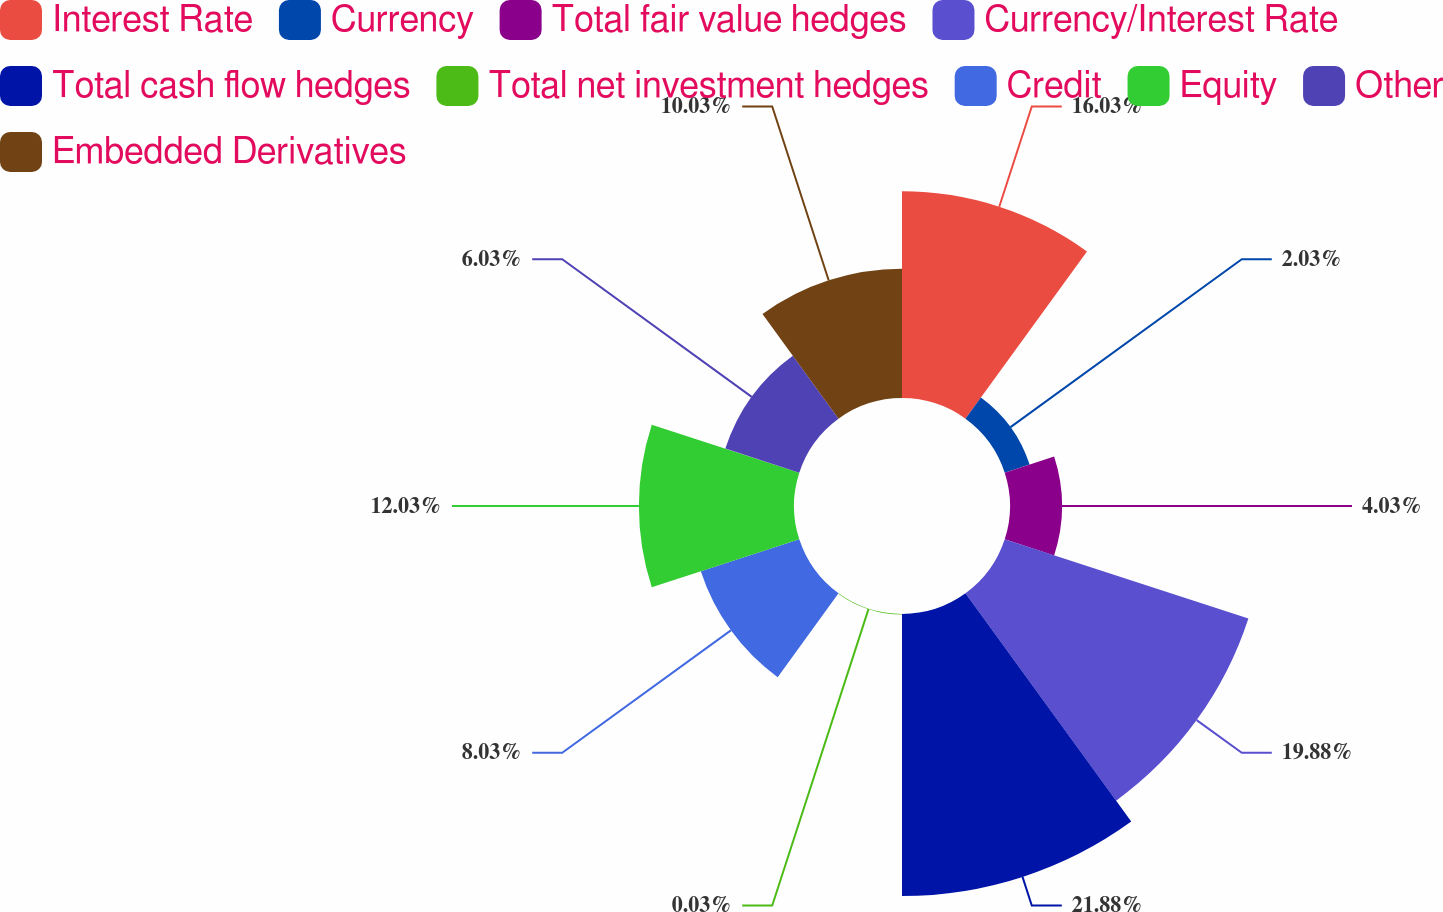Convert chart to OTSL. <chart><loc_0><loc_0><loc_500><loc_500><pie_chart><fcel>Interest Rate<fcel>Currency<fcel>Total fair value hedges<fcel>Currency/Interest Rate<fcel>Total cash flow hedges<fcel>Total net investment hedges<fcel>Credit<fcel>Equity<fcel>Other<fcel>Embedded Derivatives<nl><fcel>16.03%<fcel>2.03%<fcel>4.03%<fcel>19.87%<fcel>21.87%<fcel>0.03%<fcel>8.03%<fcel>12.03%<fcel>6.03%<fcel>10.03%<nl></chart> 